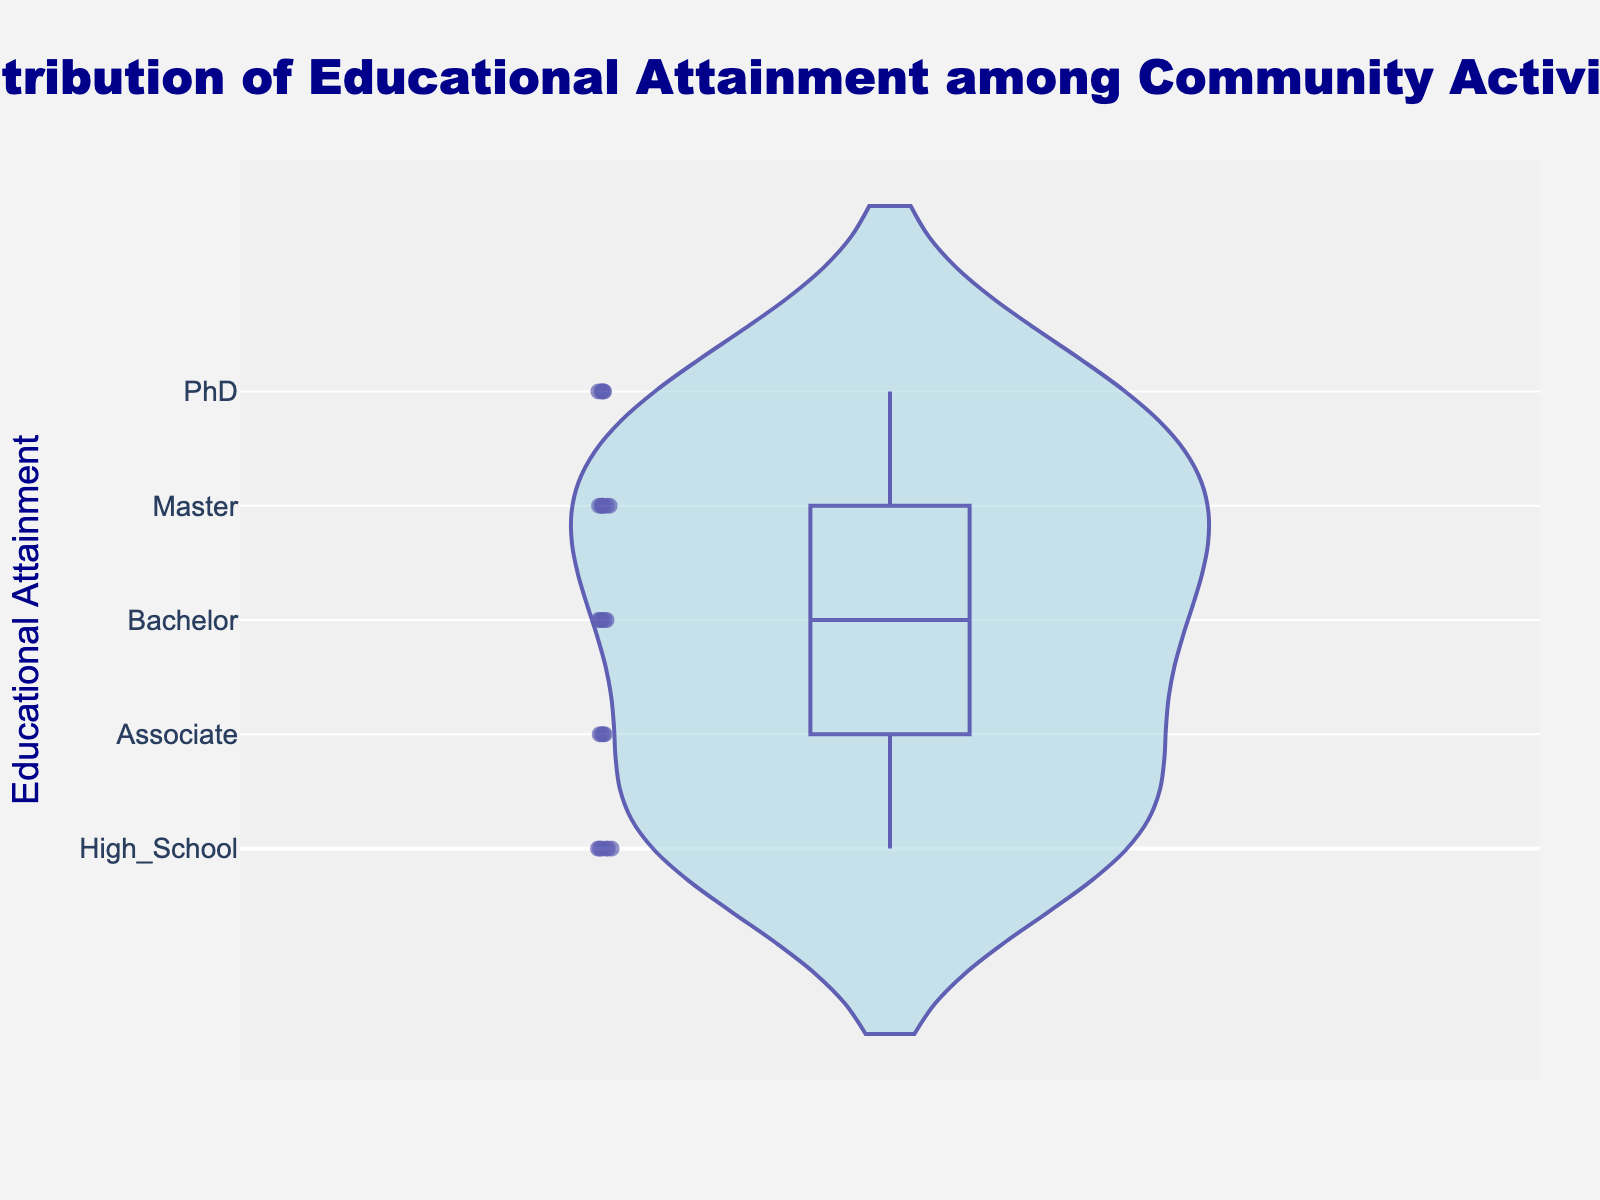What is the title of the plot? The title of the plot is located at the top of the figure and it reads "Distribution of Educational Attainment among Community Activists".
Answer: Distribution of Educational Attainment among Community Activists What does the y-axis represent? The y-axis represents the levels of educational attainment, which range from "High_School" to "PhD". These are ordered categories based on educational achievement.
Answer: Educational Attainment How many different levels of educational attainment are displayed on the y-axis? The y-axis shows 5 different levels of educational attainment, indicated by the tick labels: High_School, Associate, Bachelor, Master, and PhD.
Answer: 5 Which educational attainment level appears to have the highest median in the box plot overlay? The box plot overlay shows that "PhD" has the highest median educational attainment among the community activists, as indicated by the median line being at the topmost position.
Answer: PhD What is the mean educational attainment level based on the violin plot? The violin plot has a mean line visible, which suggests the average level of educational attainment is around the "Bachelor" or slightly above "Bachelor".
Answer: Around Bachelor Is the distribution of educational attainment among community activists symmetrical? The shape of the violin plot shows more concentration at lower educational levels and a gradual tapering towards higher levels, indicating a skewed distribution rather than symmetrical.
Answer: No What can you infer about the most common educational attainment level from the violin plot? The widest part of the violin plot, which represents the most common or frequent data points, is near "High_School" and "Bachelor", indicating these are the most common levels.
Answer: High_School and Bachelor How does the frequency of activists with an Associate degree compare to those with a Master's degree? The violin plot shows a narrower width at "Associate" compared to "Master", suggesting fewer activists have an Associate degree than a Master's degree.
Answer: Master's degree is more common How many activists have a PhD, and how does this compare to those with a High School education? The hover template in a violin plot with point positions visible allows one to count point numbers: 5 have a "PhD" and 6 have a "High School" education, showing slightly more activists with a "High School" education.
Answer: 5 (PhD) vs. 6 (High School) What insights can be drawn from the box plot overlay within the violin plot? The box plot overlay indicates the median, quartiles, and potential outliers. The median is at "Bachelor", the interquartile range spans from "High_School" to "Master", showing the diversity in educational background, with less variability at extreme levels such as "PhD".
Answer: Median at Bachelor, IQR from High_School to Master 